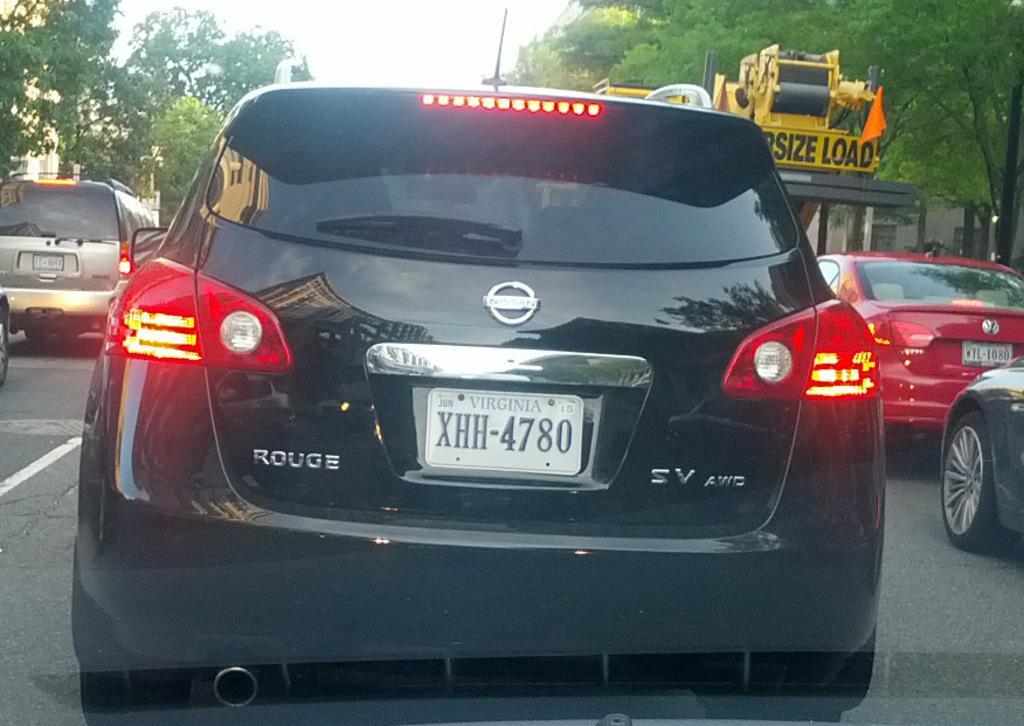Could you give a brief overview of what you see in this image? In this image I see number of cars and I see the number plate on this car on which there is something written and I see the lights. In the background I see something is written over here and I see the orange color cloth and I see number of trees. 